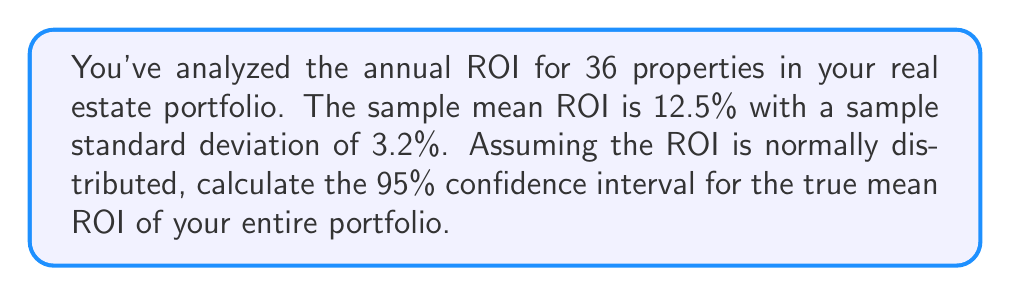Give your solution to this math problem. To calculate the confidence interval, we'll follow these steps:

1) We're using a 95% confidence level, so z* = 1.96 (from the standard normal distribution table).

2) We have:
   - Sample size (n) = 36
   - Sample mean ($\bar{x}$) = 12.5%
   - Sample standard deviation (s) = 3.2%

3) The formula for the confidence interval is:

   $$\bar{x} \pm z^* \cdot \frac{s}{\sqrt{n}}$$

4) Let's calculate the margin of error:

   $$\text{Margin of Error} = z^* \cdot \frac{s}{\sqrt{n}} = 1.96 \cdot \frac{3.2}{\sqrt{36}} = 1.96 \cdot \frac{3.2}{6} = 1.04\%$$

5) Now we can calculate the confidence interval:

   Lower bound: $12.5\% - 1.04\% = 11.46\%$
   Upper bound: $12.5\% + 1.04\% = 13.54\%$

Therefore, we are 95% confident that the true mean ROI for the entire portfolio falls between 11.46% and 13.54%.
Answer: (11.46%, 13.54%) 